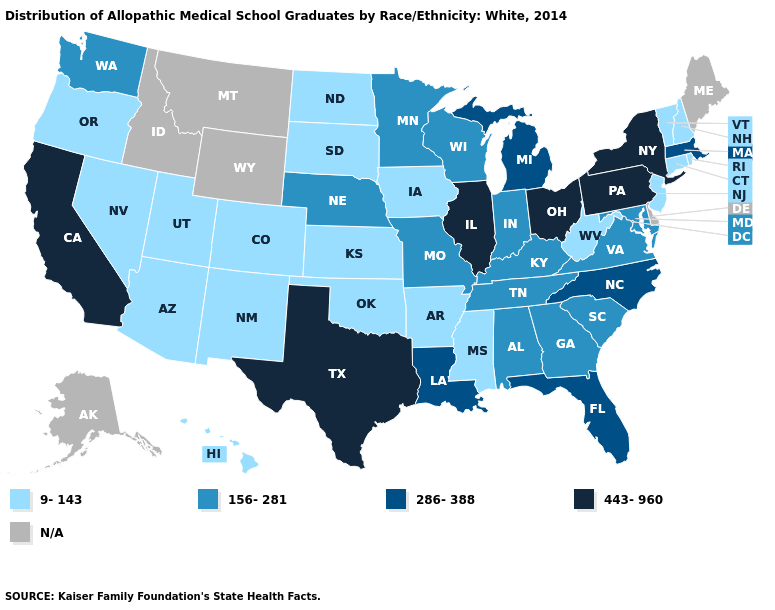Which states have the lowest value in the South?
Write a very short answer. Arkansas, Mississippi, Oklahoma, West Virginia. What is the value of Nevada?
Write a very short answer. 9-143. Which states hav the highest value in the MidWest?
Write a very short answer. Illinois, Ohio. Name the states that have a value in the range 443-960?
Quick response, please. California, Illinois, New York, Ohio, Pennsylvania, Texas. Does the map have missing data?
Be succinct. Yes. What is the value of Colorado?
Give a very brief answer. 9-143. What is the value of Tennessee?
Short answer required. 156-281. What is the value of Idaho?
Concise answer only. N/A. Name the states that have a value in the range 286-388?
Write a very short answer. Florida, Louisiana, Massachusetts, Michigan, North Carolina. What is the highest value in states that border Delaware?
Quick response, please. 443-960. Name the states that have a value in the range N/A?
Answer briefly. Alaska, Delaware, Idaho, Maine, Montana, Wyoming. What is the lowest value in the USA?
Concise answer only. 9-143. Name the states that have a value in the range 156-281?
Short answer required. Alabama, Georgia, Indiana, Kentucky, Maryland, Minnesota, Missouri, Nebraska, South Carolina, Tennessee, Virginia, Washington, Wisconsin. 